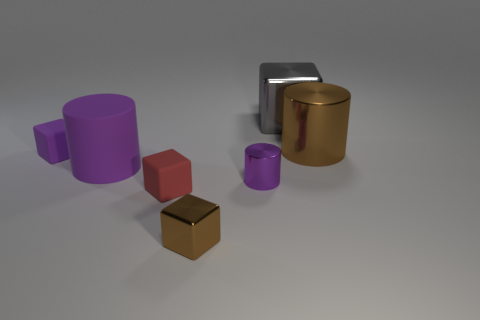What materials are the objects in the image made of? The image shows objects made of various materials. There are cylinders that appear to be metallic, one in purple and another in gold, suggesting they may be made of a metallic surface. Additionally, there are cubes that look like they're made of a rubber material, indicated by their matte finish. 